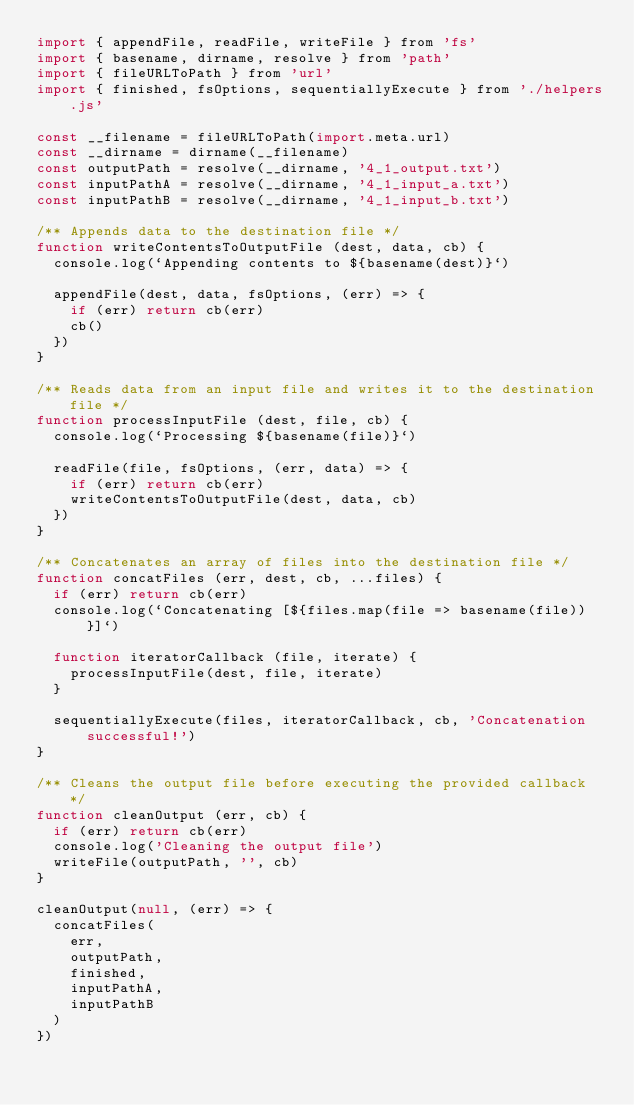Convert code to text. <code><loc_0><loc_0><loc_500><loc_500><_JavaScript_>import { appendFile, readFile, writeFile } from 'fs'
import { basename, dirname, resolve } from 'path'
import { fileURLToPath } from 'url'
import { finished, fsOptions, sequentiallyExecute } from './helpers.js'

const __filename = fileURLToPath(import.meta.url)
const __dirname = dirname(__filename)
const outputPath = resolve(__dirname, '4_1_output.txt')
const inputPathA = resolve(__dirname, '4_1_input_a.txt')
const inputPathB = resolve(__dirname, '4_1_input_b.txt')

/** Appends data to the destination file */
function writeContentsToOutputFile (dest, data, cb) {
  console.log(`Appending contents to ${basename(dest)}`)

  appendFile(dest, data, fsOptions, (err) => {
    if (err) return cb(err)
    cb()
  })
}

/** Reads data from an input file and writes it to the destination file */
function processInputFile (dest, file, cb) {
  console.log(`Processing ${basename(file)}`)

  readFile(file, fsOptions, (err, data) => {
    if (err) return cb(err)
    writeContentsToOutputFile(dest, data, cb)
  })
}

/** Concatenates an array of files into the destination file */
function concatFiles (err, dest, cb, ...files) {
  if (err) return cb(err)
  console.log(`Concatenating [${files.map(file => basename(file))}]`)

  function iteratorCallback (file, iterate) {
    processInputFile(dest, file, iterate)
  }

  sequentiallyExecute(files, iteratorCallback, cb, 'Concatenation successful!')
}

/** Cleans the output file before executing the provided callback */
function cleanOutput (err, cb) {
  if (err) return cb(err)
  console.log('Cleaning the output file')
  writeFile(outputPath, '', cb)
}

cleanOutput(null, (err) => {
  concatFiles(
    err,
    outputPath,
    finished,
    inputPathA,
    inputPathB
  )
})
</code> 